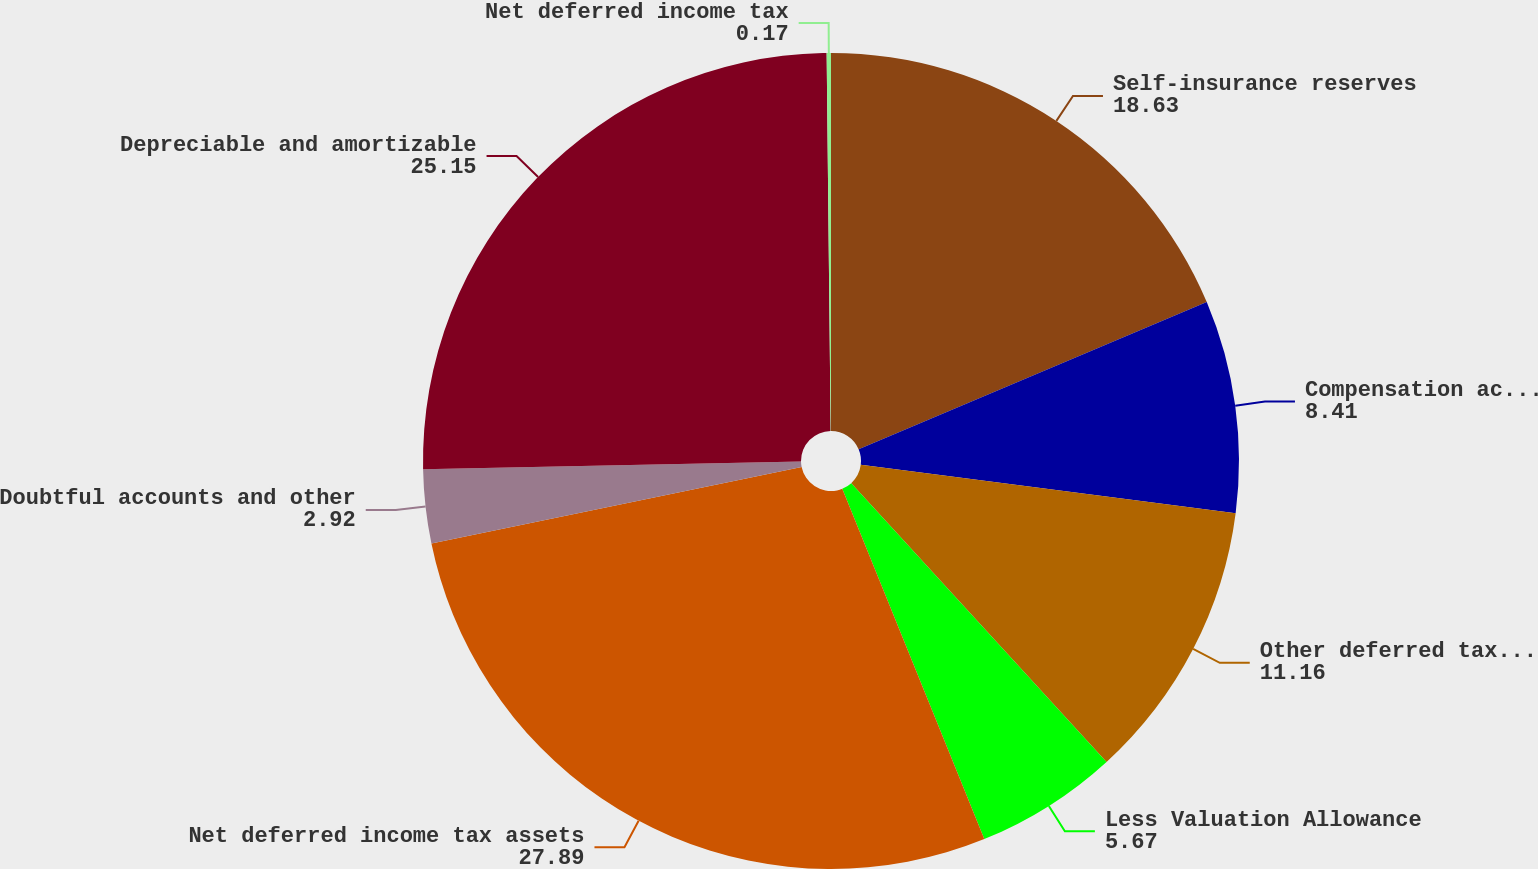Convert chart. <chart><loc_0><loc_0><loc_500><loc_500><pie_chart><fcel>Self-insurance reserves<fcel>Compensation accruals<fcel>Other deferred tax assets<fcel>Less Valuation Allowance<fcel>Net deferred income tax assets<fcel>Doubtful accounts and other<fcel>Depreciable and amortizable<fcel>Net deferred income tax<nl><fcel>18.63%<fcel>8.41%<fcel>11.16%<fcel>5.67%<fcel>27.89%<fcel>2.92%<fcel>25.15%<fcel>0.17%<nl></chart> 